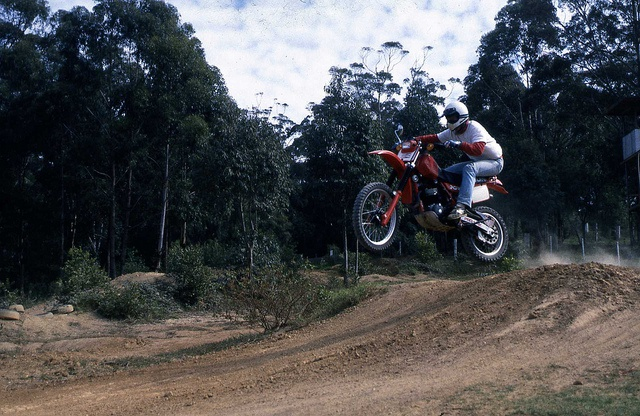Describe the objects in this image and their specific colors. I can see motorcycle in navy, black, gray, and maroon tones and people in navy, black, white, and gray tones in this image. 